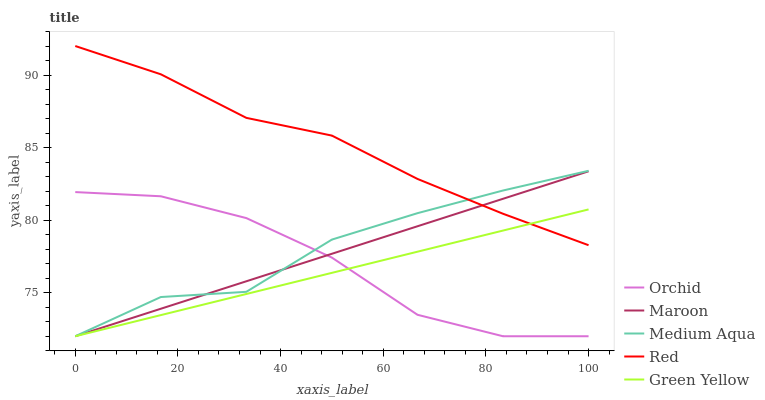Does Green Yellow have the minimum area under the curve?
Answer yes or no. Yes. Does Red have the maximum area under the curve?
Answer yes or no. Yes. Does Medium Aqua have the minimum area under the curve?
Answer yes or no. No. Does Medium Aqua have the maximum area under the curve?
Answer yes or no. No. Is Maroon the smoothest?
Answer yes or no. Yes. Is Medium Aqua the roughest?
Answer yes or no. Yes. Is Red the smoothest?
Answer yes or no. No. Is Red the roughest?
Answer yes or no. No. Does Green Yellow have the lowest value?
Answer yes or no. Yes. Does Red have the lowest value?
Answer yes or no. No. Does Red have the highest value?
Answer yes or no. Yes. Does Medium Aqua have the highest value?
Answer yes or no. No. Is Orchid less than Red?
Answer yes or no. Yes. Is Red greater than Orchid?
Answer yes or no. Yes. Does Orchid intersect Green Yellow?
Answer yes or no. Yes. Is Orchid less than Green Yellow?
Answer yes or no. No. Is Orchid greater than Green Yellow?
Answer yes or no. No. Does Orchid intersect Red?
Answer yes or no. No. 